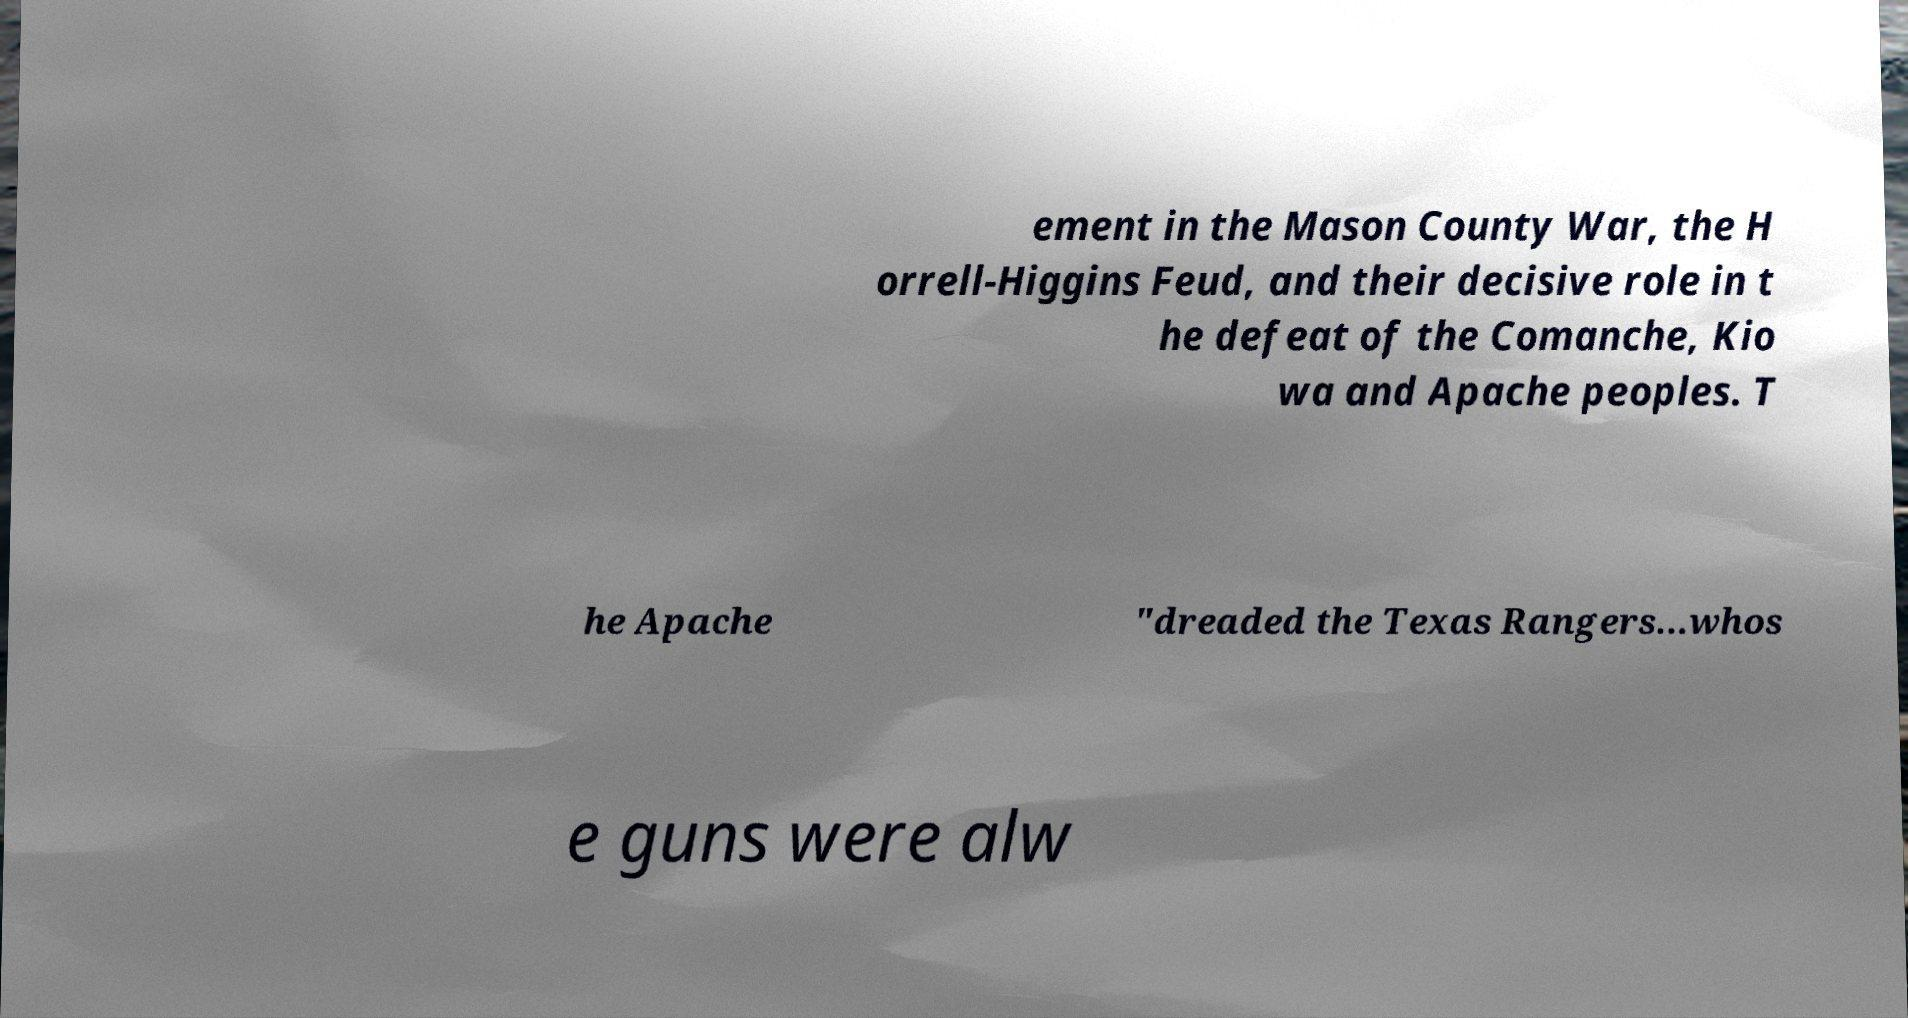Can you accurately transcribe the text from the provided image for me? ement in the Mason County War, the H orrell-Higgins Feud, and their decisive role in t he defeat of the Comanche, Kio wa and Apache peoples. T he Apache "dreaded the Texas Rangers...whos e guns were alw 